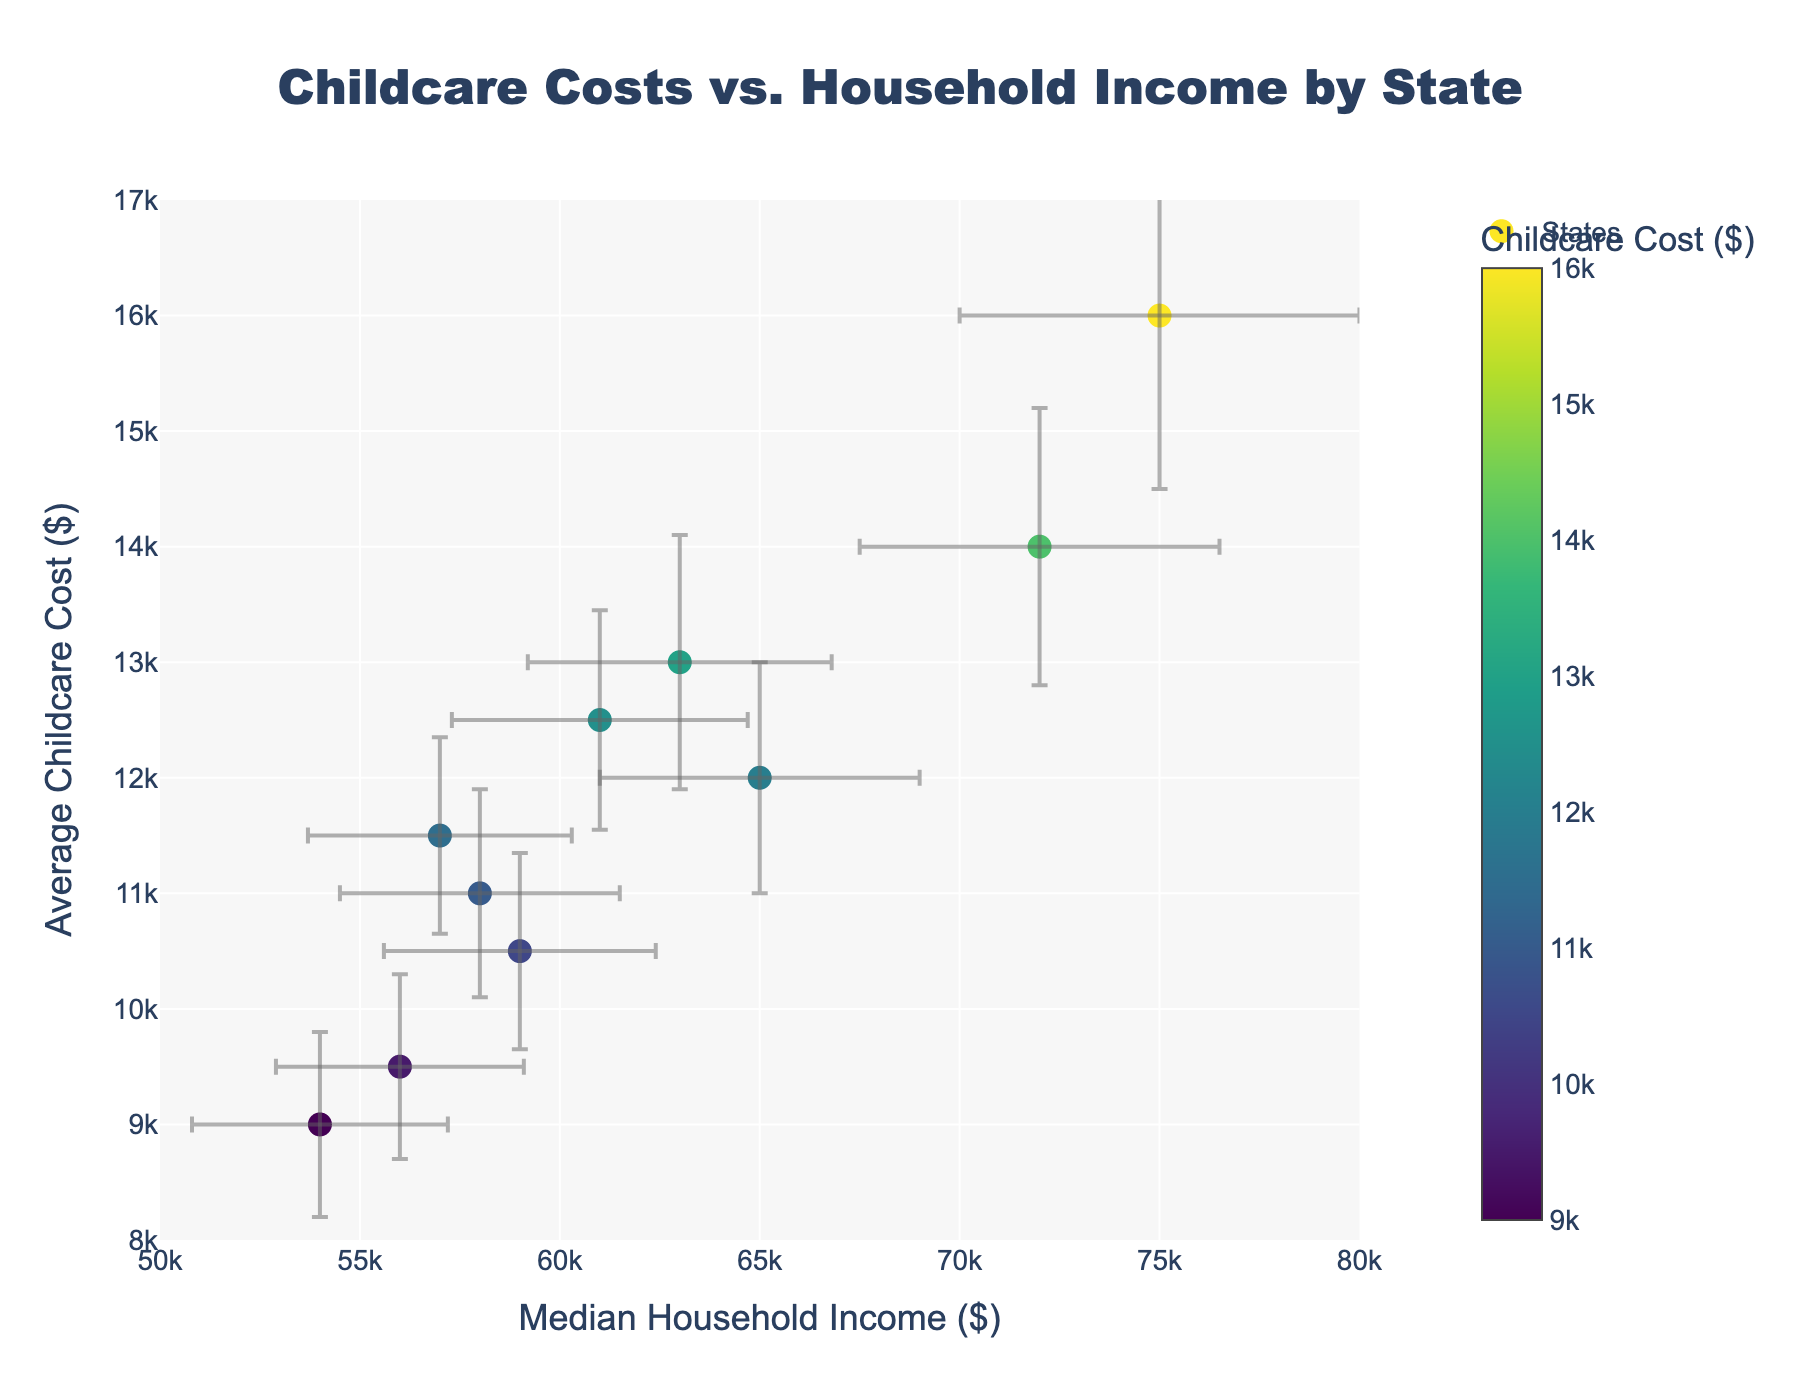What's the title of the figure? The title of the figure is usually displayed at the top. In this case, it's "Childcare Costs vs. Household Income by State".
Answer: Childcare Costs vs. Household Income by State What is the range of the x-axis? The x-axis range represents the range of Median Household Income shown on the plot. From the axis marks, it is clear that the range is from $50,000 to $80,000.
Answer: $50,000 to $80,000 What is the income variability for Ohio? Income variability is shown by the error bars around each data point. For Ohio, located on the x-axis at $54,000, the error bar reaches $3,200 on either side. This indicates an income variability of $3,200.
Answer: $3,200 How does the variability in Average Childcare Cost compare between California and New York? Comparing the error bars vertically for both California and New York, California's error bar extends by $1,500 and New York's by $1,200 from their respective average childcare costs. California has a higher variability in childcare costs.
Answer: California has higher variability Which state shows the highest average childcare cost, and what is that cost? According to the y-axis position and the color shading indicating higher childcare costs, California shows the highest average childcare cost at $16,000.
Answer: California, $16,000 Can you identify the state with the lowest median household income shown on the plot? The state with the lowest median household income has the lowest x-axis value, which is $54,000 for Ohio.
Answer: Ohio What is the relationship between median household income and average childcare cost in the figure? The scatter plot generally shows data points clustering upwards as household income increases, indicating a positive relationship where higher household incomes typically correspond to higher childcare costs.
Answer: Positive relationship Which state has a median household income closest to $60,000? The state closest to $60,000 median household income is Florida, marked at $58,000.
Answer: Florida What states have an average childcare cost between $11,000 and $13,000, and what are their specific costs? The states with average childcare costs between $11,000 and $13,000 are Florida ($11,000), Illinois ($13,000), and North Carolina ($11,500).
Answer: Florida, Illinois, North Carolina How does Florida's income and cost variability generally compare to other states? To compare, observe the lengths of the error bars. Florida's income variability is $3,500 and childcare cost variability is $900, both of which are roughly average compared to other states.
Answer: Average 